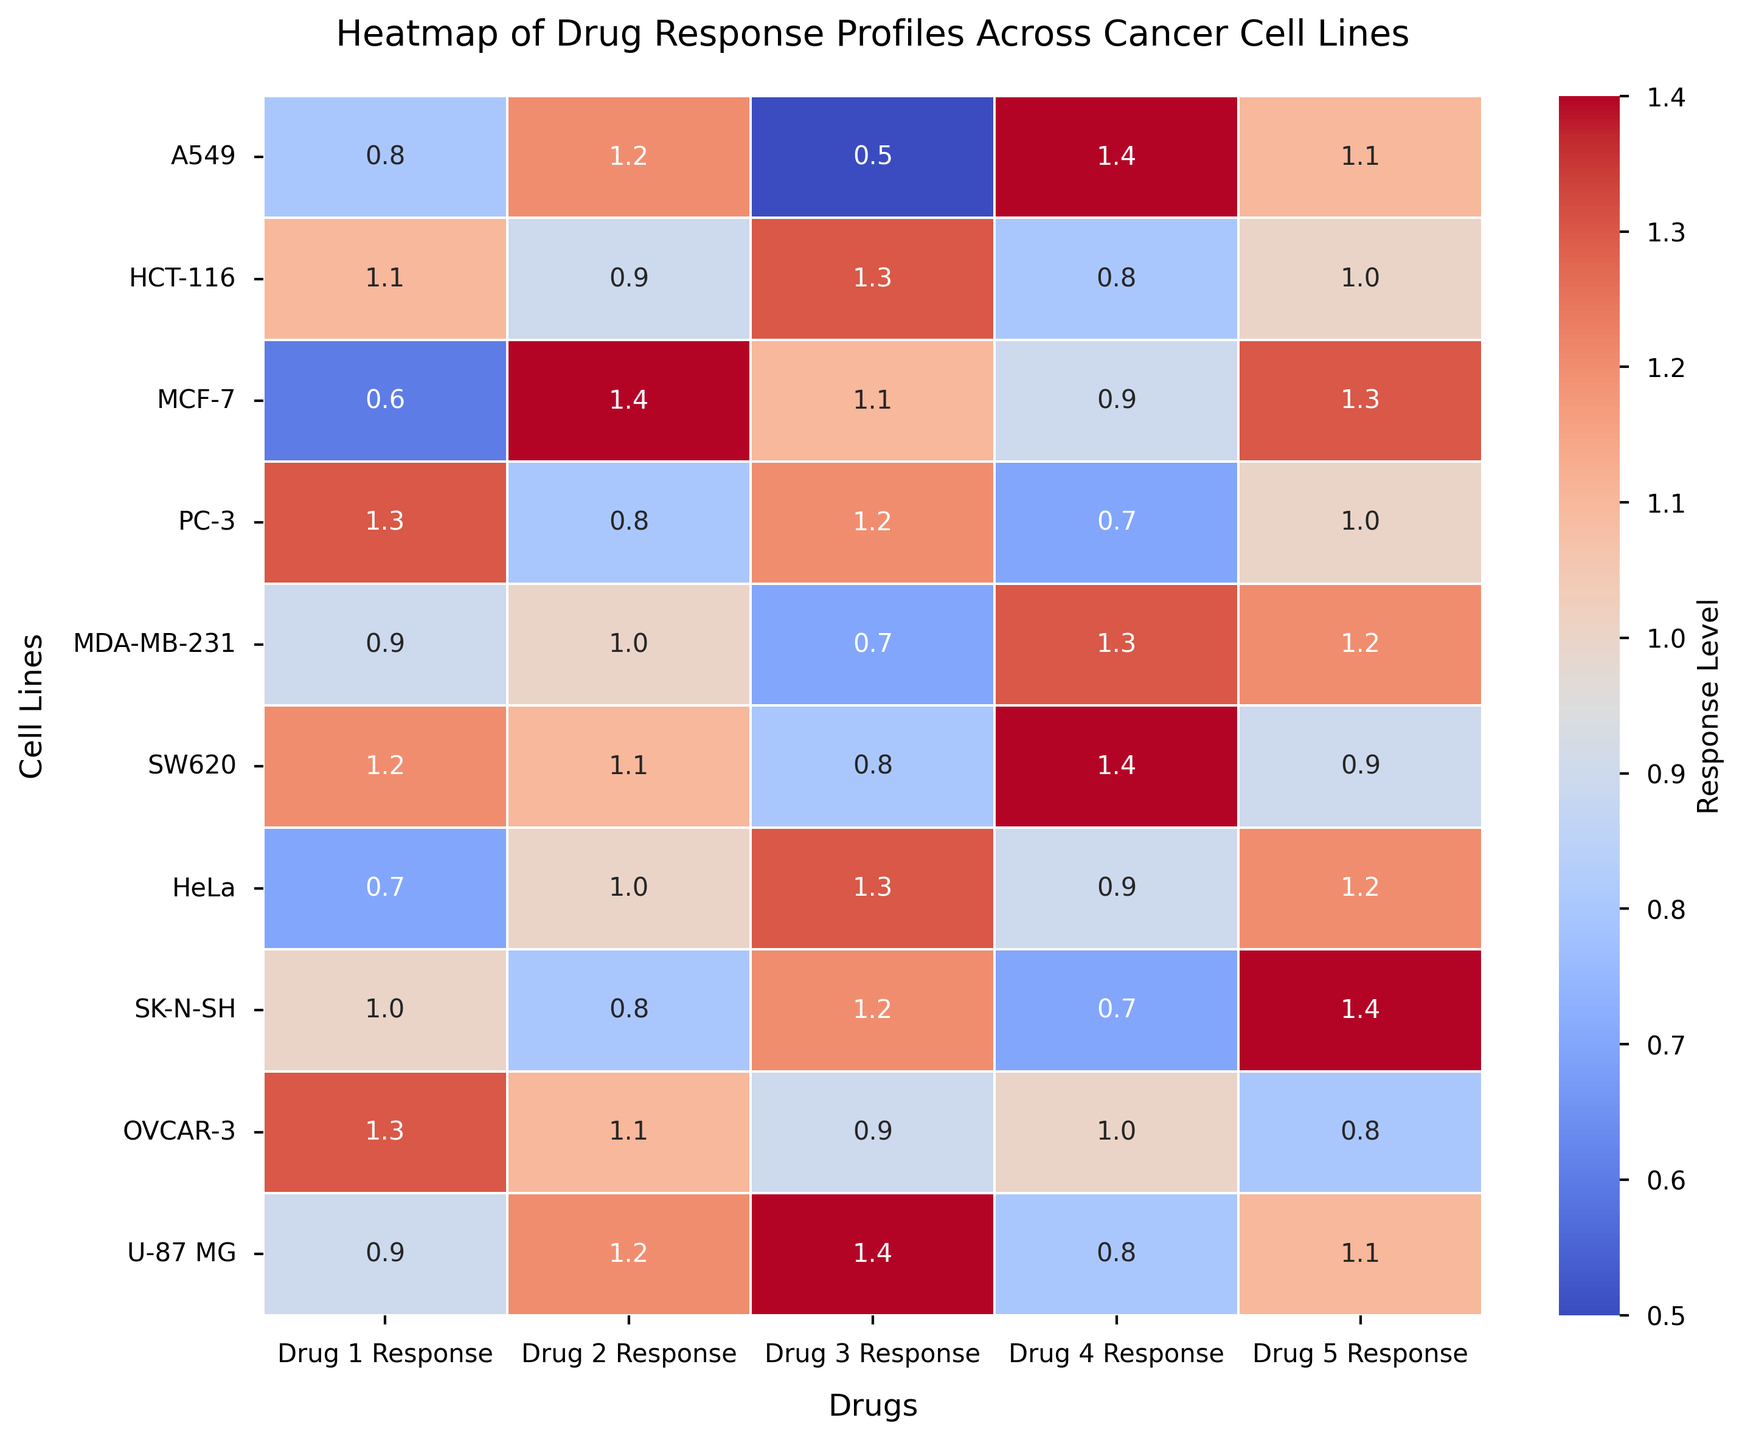Which cell line has the highest response to Drug 2? To find the highest response to Drug 2, scan the Drug 2 column for the maximum value. The highest value in this column is 1.4 for MCF-7.
Answer: MCF-7 Which drug shows the most consistent response across all cell lines? Check the variance of responses for each drug across all cell lines. The drug with the smallest variance (most consistent values) is Drug 5.
Answer: Drug 5 What's the average response of Drug 1 across all cell lines? Sum the responses of Drug 1 for all cell lines (0.8 + 1.1 + 0.6 + 1.3 + 0.9 + 1.2 + 0.7 + 1.0 + 1.3 + 0.9) = 9.8, then divide by the number of cell lines (10), so the average is 9.8/10.
Answer: 0.98 Which cell line has the most variable response across all drugs? Check the variance of the responses across all drugs for each cell line. The cell line with the highest variance is U-87 MG.
Answer: U-87 MG Is the response of Drug 4 generally higher or lower than that of Drug 3 for most cell lines? Compare responses of Drug 4 and Drug 3 for each cell line. Drug 4 responses: 1.4, 0.8, 0.9, 0.7, 1.3, 1.4, 0.9, 0.7, 1.0, 0.8; Drug 3 responses: 0.5, 1.3, 1.1, 1.2, 0.7, 0.8, 1.3, 1.2, 0.9, 1.4. Notice that Drug 4 is higher than Drug 3 for most cell lines.
Answer: Higher What is the ratio of the highest response to the lowest response for HCT-116 cell line? For HCT-116, the highest response is 1.3 (Drug 3) and the lowest is 0.8 (Drug 4). The ratio is 1.3 / 0.8 = 1.625.
Answer: 1.625 Which cell line has the closest responses to Drugs 1 and 5? Observe the differences between responses of Drugs 1 and 5 for each cell line. A549 (0.8 and 1.1, difference = 0.3), HCT-116 (1.1 and 1.0, difference = 0.1), MCF-7 (0.6 and 1.3, difference = 0.7), and so on. The smallest difference is for HCT-116.
Answer: HCT-116 Are there any drugs for which all cell lines have a response higher than 0.7? Check each drug's responses across all cell lines to see if all values are greater than 0.7. Drug 2 has all responses higher than 0.7.
Answer: Drug 2 What's the color associated with the highest response level on the heatmap? Identify the color at the position of the highest response value (1.4) on the heatmap. The color corresponds to deep red.
Answer: Red 